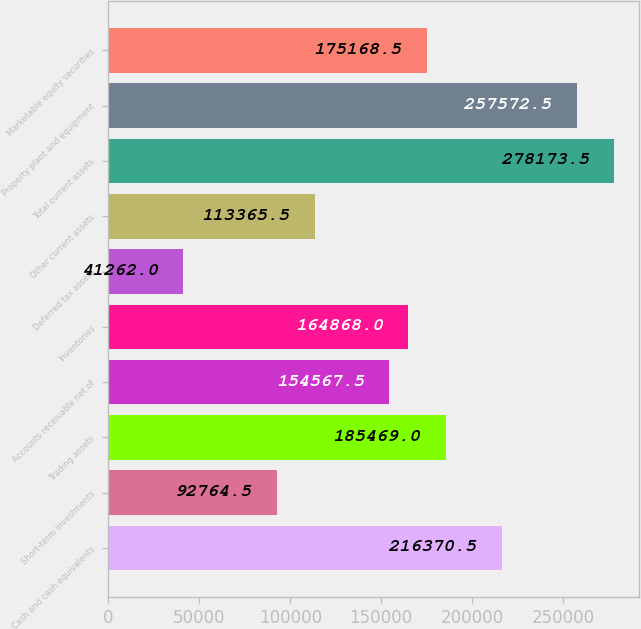Convert chart to OTSL. <chart><loc_0><loc_0><loc_500><loc_500><bar_chart><fcel>Cash and cash equivalents<fcel>Short-term investments<fcel>Trading assets<fcel>Accounts receivable net of<fcel>Inventories<fcel>Deferred tax assets<fcel>Other current assets<fcel>Total current assets<fcel>Property plant and equipment<fcel>Marketable equity securities<nl><fcel>216370<fcel>92764.5<fcel>185469<fcel>154568<fcel>164868<fcel>41262<fcel>113366<fcel>278174<fcel>257572<fcel>175168<nl></chart> 